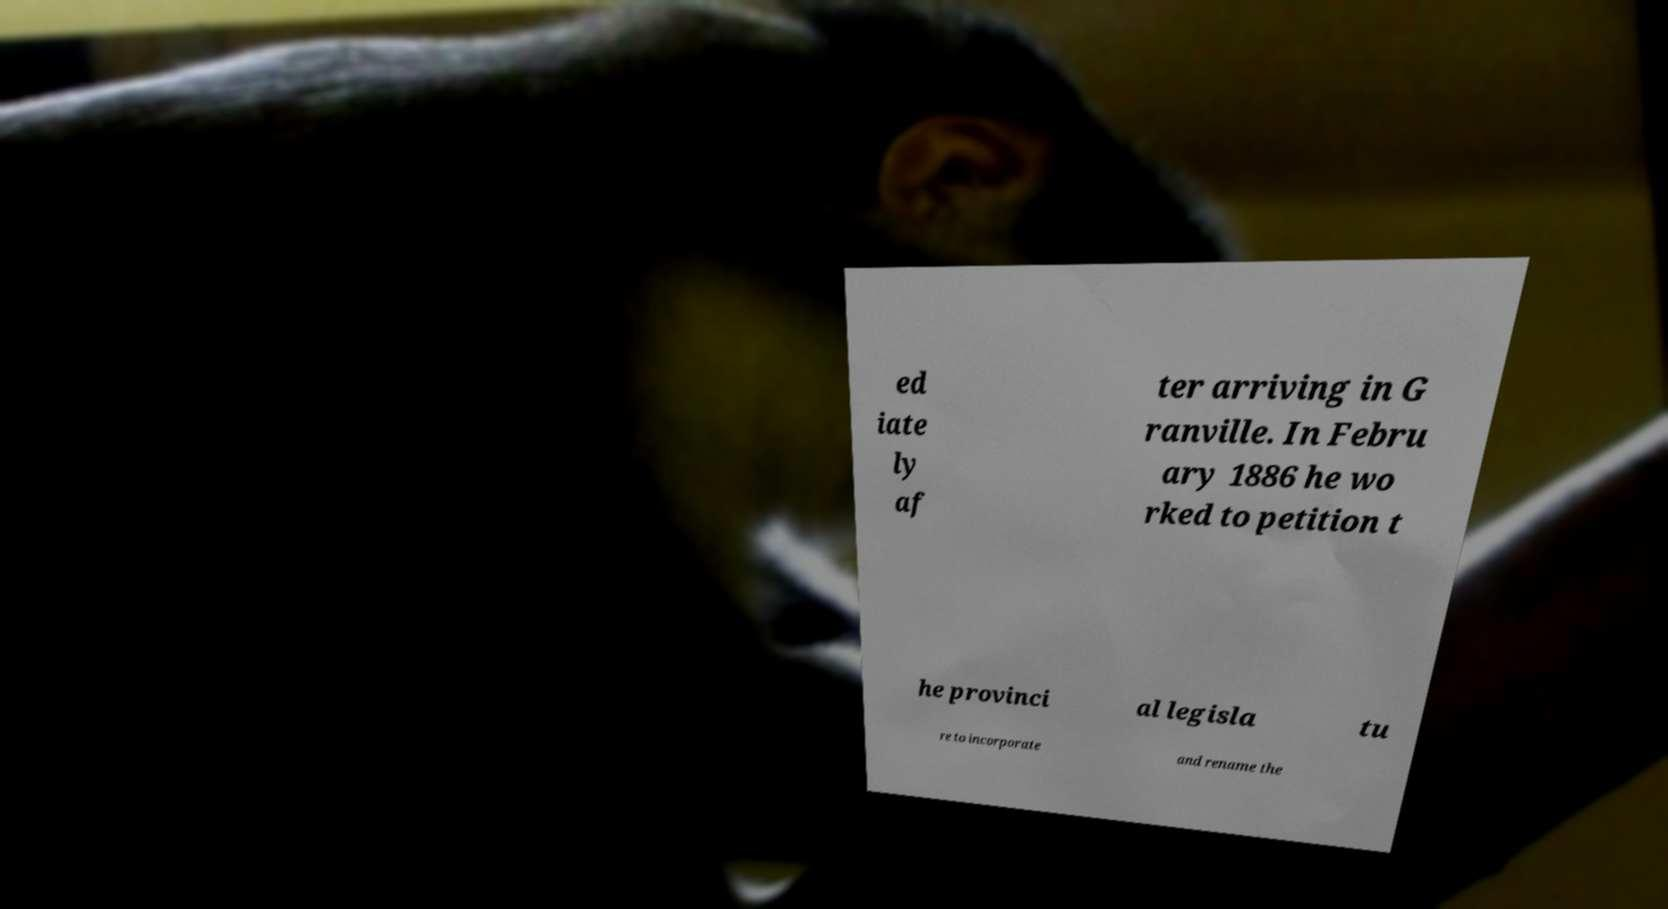Can you read and provide the text displayed in the image?This photo seems to have some interesting text. Can you extract and type it out for me? ed iate ly af ter arriving in G ranville. In Febru ary 1886 he wo rked to petition t he provinci al legisla tu re to incorporate and rename the 